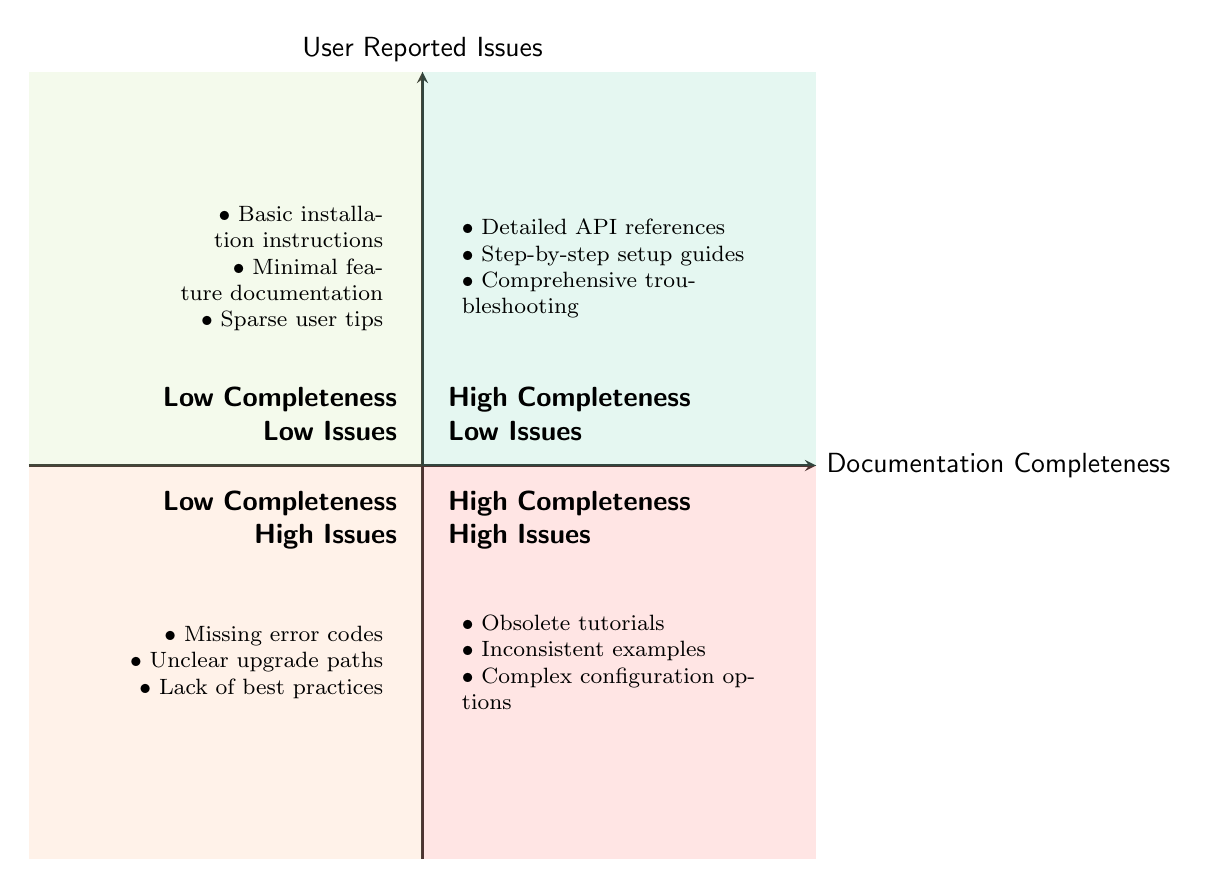What is found in the "High Documentation Completeness - Low User Reported Issues" quadrant? In this quadrant, documentation items that are comprehensive and lead to few user-reported issues are listed. They include "Detailed API references," "Step-by-step setup guides," and "Comprehensive troubleshooting section."
Answer: Detailed API references, Step-by-step setup guides, Comprehensive troubleshooting section What types of issues are documented in the "Low Documentation Completeness - High User Reported Issues"? This quadrant highlights the impact of poor documentation, where items like "Missing error codes," "Unclear upgrade paths," and "Lack of best practices" lead to many user-reported issues.
Answer: Missing error codes, Unclear upgrade paths, Lack of best practices How many items are listed in the "High Documentation Completeness - High User Reported Issues"? In this quadrant, there are three items listed: "Obsolete tutorials," "Inconsistent examples," and "Complex configuration options." Thus, the total count is three.
Answer: 3 What do the quadrants illustrate about the relationship between documentation completeness and user-reported issues? The quadrants categorize documentation effectiveness and user-reported issues, emphasizing that high completeness generally correlates with lower user-reported issues, while low completeness often results in high issues.
Answer: Relationship impacts Which quadrant contains "Basic installation instructions"? The "Basic installation instructions" are found in the "Low Documentation Completeness - Low User Reported Issues" quadrant, indicating that while the documentation is minimal, it doesn't lead to significant user issues.
Answer: Low Documentation Completeness - Low User Reported Issues What does the presence of inconsistent examples indicate about documentation quality? The presence of "Inconsistent examples" in the "High Documentation Completeness - High User Reported Issues" quadrant indicates that even with comprehensive documentation, if examples are not consistent, it can result in a high number of user-reported issues.
Answer: High issues despite completeness 